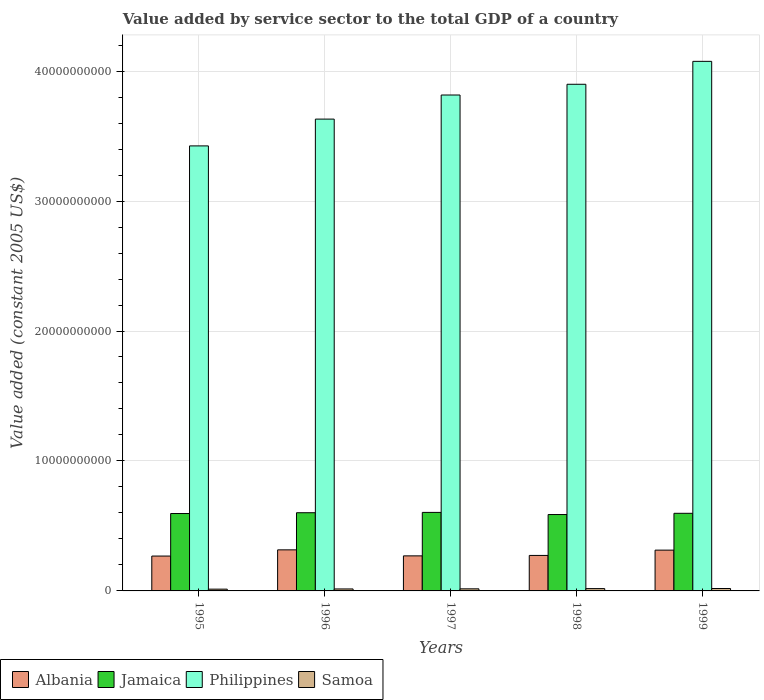How many different coloured bars are there?
Your answer should be very brief. 4. How many groups of bars are there?
Your response must be concise. 5. Are the number of bars per tick equal to the number of legend labels?
Give a very brief answer. Yes. Are the number of bars on each tick of the X-axis equal?
Give a very brief answer. Yes. What is the label of the 4th group of bars from the left?
Make the answer very short. 1998. In how many cases, is the number of bars for a given year not equal to the number of legend labels?
Offer a very short reply. 0. What is the value added by service sector in Samoa in 1996?
Ensure brevity in your answer.  1.52e+08. Across all years, what is the maximum value added by service sector in Albania?
Your answer should be compact. 3.16e+09. Across all years, what is the minimum value added by service sector in Jamaica?
Your response must be concise. 5.88e+09. In which year was the value added by service sector in Jamaica minimum?
Offer a terse response. 1998. What is the total value added by service sector in Albania in the graph?
Offer a terse response. 1.44e+1. What is the difference between the value added by service sector in Albania in 1995 and that in 1998?
Keep it short and to the point. -4.81e+07. What is the difference between the value added by service sector in Philippines in 1998 and the value added by service sector in Jamaica in 1995?
Your response must be concise. 3.30e+1. What is the average value added by service sector in Samoa per year?
Your answer should be compact. 1.63e+08. In the year 1996, what is the difference between the value added by service sector in Jamaica and value added by service sector in Albania?
Provide a succinct answer. 2.86e+09. In how many years, is the value added by service sector in Jamaica greater than 38000000000 US$?
Make the answer very short. 0. What is the ratio of the value added by service sector in Philippines in 1995 to that in 1996?
Ensure brevity in your answer.  0.94. Is the value added by service sector in Samoa in 1996 less than that in 1999?
Ensure brevity in your answer.  Yes. Is the difference between the value added by service sector in Jamaica in 1998 and 1999 greater than the difference between the value added by service sector in Albania in 1998 and 1999?
Provide a succinct answer. Yes. What is the difference between the highest and the second highest value added by service sector in Jamaica?
Your answer should be very brief. 2.46e+07. What is the difference between the highest and the lowest value added by service sector in Samoa?
Offer a terse response. 4.87e+07. Is the sum of the value added by service sector in Philippines in 1997 and 1998 greater than the maximum value added by service sector in Samoa across all years?
Provide a succinct answer. Yes. What does the 4th bar from the left in 1996 represents?
Your response must be concise. Samoa. What does the 3rd bar from the right in 1998 represents?
Provide a short and direct response. Jamaica. Is it the case that in every year, the sum of the value added by service sector in Samoa and value added by service sector in Albania is greater than the value added by service sector in Philippines?
Give a very brief answer. No. How many bars are there?
Provide a short and direct response. 20. Does the graph contain grids?
Provide a short and direct response. Yes. What is the title of the graph?
Provide a short and direct response. Value added by service sector to the total GDP of a country. What is the label or title of the X-axis?
Offer a very short reply. Years. What is the label or title of the Y-axis?
Provide a succinct answer. Value added (constant 2005 US$). What is the Value added (constant 2005 US$) in Albania in 1995?
Make the answer very short. 2.68e+09. What is the Value added (constant 2005 US$) of Jamaica in 1995?
Your answer should be very brief. 5.96e+09. What is the Value added (constant 2005 US$) in Philippines in 1995?
Keep it short and to the point. 3.42e+1. What is the Value added (constant 2005 US$) of Samoa in 1995?
Offer a terse response. 1.37e+08. What is the Value added (constant 2005 US$) of Albania in 1996?
Offer a very short reply. 3.16e+09. What is the Value added (constant 2005 US$) in Jamaica in 1996?
Your response must be concise. 6.02e+09. What is the Value added (constant 2005 US$) in Philippines in 1996?
Your response must be concise. 3.63e+1. What is the Value added (constant 2005 US$) of Samoa in 1996?
Your answer should be compact. 1.52e+08. What is the Value added (constant 2005 US$) in Albania in 1997?
Provide a short and direct response. 2.70e+09. What is the Value added (constant 2005 US$) of Jamaica in 1997?
Give a very brief answer. 6.04e+09. What is the Value added (constant 2005 US$) of Philippines in 1997?
Offer a very short reply. 3.82e+1. What is the Value added (constant 2005 US$) of Samoa in 1997?
Offer a very short reply. 1.60e+08. What is the Value added (constant 2005 US$) in Albania in 1998?
Offer a very short reply. 2.73e+09. What is the Value added (constant 2005 US$) in Jamaica in 1998?
Give a very brief answer. 5.88e+09. What is the Value added (constant 2005 US$) in Philippines in 1998?
Provide a short and direct response. 3.90e+1. What is the Value added (constant 2005 US$) in Samoa in 1998?
Provide a succinct answer. 1.78e+08. What is the Value added (constant 2005 US$) of Albania in 1999?
Your answer should be very brief. 3.14e+09. What is the Value added (constant 2005 US$) of Jamaica in 1999?
Offer a terse response. 5.97e+09. What is the Value added (constant 2005 US$) of Philippines in 1999?
Your answer should be very brief. 4.07e+1. What is the Value added (constant 2005 US$) in Samoa in 1999?
Provide a succinct answer. 1.86e+08. Across all years, what is the maximum Value added (constant 2005 US$) of Albania?
Provide a succinct answer. 3.16e+09. Across all years, what is the maximum Value added (constant 2005 US$) in Jamaica?
Ensure brevity in your answer.  6.04e+09. Across all years, what is the maximum Value added (constant 2005 US$) in Philippines?
Your answer should be compact. 4.07e+1. Across all years, what is the maximum Value added (constant 2005 US$) in Samoa?
Ensure brevity in your answer.  1.86e+08. Across all years, what is the minimum Value added (constant 2005 US$) in Albania?
Ensure brevity in your answer.  2.68e+09. Across all years, what is the minimum Value added (constant 2005 US$) in Jamaica?
Make the answer very short. 5.88e+09. Across all years, what is the minimum Value added (constant 2005 US$) in Philippines?
Offer a very short reply. 3.42e+1. Across all years, what is the minimum Value added (constant 2005 US$) of Samoa?
Give a very brief answer. 1.37e+08. What is the total Value added (constant 2005 US$) in Albania in the graph?
Offer a terse response. 1.44e+1. What is the total Value added (constant 2005 US$) of Jamaica in the graph?
Offer a terse response. 2.99e+1. What is the total Value added (constant 2005 US$) of Philippines in the graph?
Ensure brevity in your answer.  1.88e+11. What is the total Value added (constant 2005 US$) of Samoa in the graph?
Provide a succinct answer. 8.13e+08. What is the difference between the Value added (constant 2005 US$) in Albania in 1995 and that in 1996?
Keep it short and to the point. -4.78e+08. What is the difference between the Value added (constant 2005 US$) in Jamaica in 1995 and that in 1996?
Your response must be concise. -6.16e+07. What is the difference between the Value added (constant 2005 US$) in Philippines in 1995 and that in 1996?
Keep it short and to the point. -2.06e+09. What is the difference between the Value added (constant 2005 US$) of Samoa in 1995 and that in 1996?
Your answer should be compact. -1.48e+07. What is the difference between the Value added (constant 2005 US$) of Albania in 1995 and that in 1997?
Offer a very short reply. -1.41e+07. What is the difference between the Value added (constant 2005 US$) in Jamaica in 1995 and that in 1997?
Your response must be concise. -8.62e+07. What is the difference between the Value added (constant 2005 US$) of Philippines in 1995 and that in 1997?
Ensure brevity in your answer.  -3.92e+09. What is the difference between the Value added (constant 2005 US$) in Samoa in 1995 and that in 1997?
Your answer should be compact. -2.35e+07. What is the difference between the Value added (constant 2005 US$) of Albania in 1995 and that in 1998?
Give a very brief answer. -4.81e+07. What is the difference between the Value added (constant 2005 US$) of Jamaica in 1995 and that in 1998?
Your response must be concise. 7.83e+07. What is the difference between the Value added (constant 2005 US$) of Philippines in 1995 and that in 1998?
Offer a terse response. -4.74e+09. What is the difference between the Value added (constant 2005 US$) of Samoa in 1995 and that in 1998?
Keep it short and to the point. -4.14e+07. What is the difference between the Value added (constant 2005 US$) of Albania in 1995 and that in 1999?
Keep it short and to the point. -4.56e+08. What is the difference between the Value added (constant 2005 US$) in Jamaica in 1995 and that in 1999?
Provide a succinct answer. -1.67e+07. What is the difference between the Value added (constant 2005 US$) in Philippines in 1995 and that in 1999?
Offer a very short reply. -6.51e+09. What is the difference between the Value added (constant 2005 US$) of Samoa in 1995 and that in 1999?
Provide a short and direct response. -4.87e+07. What is the difference between the Value added (constant 2005 US$) in Albania in 1996 and that in 1997?
Provide a succinct answer. 4.64e+08. What is the difference between the Value added (constant 2005 US$) in Jamaica in 1996 and that in 1997?
Ensure brevity in your answer.  -2.46e+07. What is the difference between the Value added (constant 2005 US$) in Philippines in 1996 and that in 1997?
Your answer should be very brief. -1.85e+09. What is the difference between the Value added (constant 2005 US$) in Samoa in 1996 and that in 1997?
Give a very brief answer. -8.70e+06. What is the difference between the Value added (constant 2005 US$) of Albania in 1996 and that in 1998?
Your answer should be very brief. 4.30e+08. What is the difference between the Value added (constant 2005 US$) of Jamaica in 1996 and that in 1998?
Your answer should be compact. 1.40e+08. What is the difference between the Value added (constant 2005 US$) of Philippines in 1996 and that in 1998?
Keep it short and to the point. -2.68e+09. What is the difference between the Value added (constant 2005 US$) in Samoa in 1996 and that in 1998?
Provide a succinct answer. -2.65e+07. What is the difference between the Value added (constant 2005 US$) in Albania in 1996 and that in 1999?
Keep it short and to the point. 2.20e+07. What is the difference between the Value added (constant 2005 US$) in Jamaica in 1996 and that in 1999?
Ensure brevity in your answer.  4.48e+07. What is the difference between the Value added (constant 2005 US$) in Philippines in 1996 and that in 1999?
Your response must be concise. -4.44e+09. What is the difference between the Value added (constant 2005 US$) of Samoa in 1996 and that in 1999?
Offer a very short reply. -3.39e+07. What is the difference between the Value added (constant 2005 US$) in Albania in 1997 and that in 1998?
Your response must be concise. -3.40e+07. What is the difference between the Value added (constant 2005 US$) of Jamaica in 1997 and that in 1998?
Offer a terse response. 1.64e+08. What is the difference between the Value added (constant 2005 US$) of Philippines in 1997 and that in 1998?
Provide a succinct answer. -8.26e+08. What is the difference between the Value added (constant 2005 US$) in Samoa in 1997 and that in 1998?
Your answer should be compact. -1.78e+07. What is the difference between the Value added (constant 2005 US$) in Albania in 1997 and that in 1999?
Provide a short and direct response. -4.42e+08. What is the difference between the Value added (constant 2005 US$) in Jamaica in 1997 and that in 1999?
Give a very brief answer. 6.94e+07. What is the difference between the Value added (constant 2005 US$) in Philippines in 1997 and that in 1999?
Offer a terse response. -2.59e+09. What is the difference between the Value added (constant 2005 US$) of Samoa in 1997 and that in 1999?
Make the answer very short. -2.52e+07. What is the difference between the Value added (constant 2005 US$) in Albania in 1998 and that in 1999?
Give a very brief answer. -4.08e+08. What is the difference between the Value added (constant 2005 US$) of Jamaica in 1998 and that in 1999?
Keep it short and to the point. -9.51e+07. What is the difference between the Value added (constant 2005 US$) of Philippines in 1998 and that in 1999?
Offer a very short reply. -1.76e+09. What is the difference between the Value added (constant 2005 US$) of Samoa in 1998 and that in 1999?
Ensure brevity in your answer.  -7.37e+06. What is the difference between the Value added (constant 2005 US$) in Albania in 1995 and the Value added (constant 2005 US$) in Jamaica in 1996?
Keep it short and to the point. -3.33e+09. What is the difference between the Value added (constant 2005 US$) in Albania in 1995 and the Value added (constant 2005 US$) in Philippines in 1996?
Offer a terse response. -3.36e+1. What is the difference between the Value added (constant 2005 US$) in Albania in 1995 and the Value added (constant 2005 US$) in Samoa in 1996?
Keep it short and to the point. 2.53e+09. What is the difference between the Value added (constant 2005 US$) in Jamaica in 1995 and the Value added (constant 2005 US$) in Philippines in 1996?
Give a very brief answer. -3.03e+1. What is the difference between the Value added (constant 2005 US$) of Jamaica in 1995 and the Value added (constant 2005 US$) of Samoa in 1996?
Give a very brief answer. 5.80e+09. What is the difference between the Value added (constant 2005 US$) in Philippines in 1995 and the Value added (constant 2005 US$) in Samoa in 1996?
Provide a succinct answer. 3.41e+1. What is the difference between the Value added (constant 2005 US$) of Albania in 1995 and the Value added (constant 2005 US$) of Jamaica in 1997?
Offer a terse response. -3.36e+09. What is the difference between the Value added (constant 2005 US$) of Albania in 1995 and the Value added (constant 2005 US$) of Philippines in 1997?
Your response must be concise. -3.55e+1. What is the difference between the Value added (constant 2005 US$) of Albania in 1995 and the Value added (constant 2005 US$) of Samoa in 1997?
Offer a terse response. 2.52e+09. What is the difference between the Value added (constant 2005 US$) of Jamaica in 1995 and the Value added (constant 2005 US$) of Philippines in 1997?
Your answer should be compact. -3.22e+1. What is the difference between the Value added (constant 2005 US$) in Jamaica in 1995 and the Value added (constant 2005 US$) in Samoa in 1997?
Provide a succinct answer. 5.80e+09. What is the difference between the Value added (constant 2005 US$) in Philippines in 1995 and the Value added (constant 2005 US$) in Samoa in 1997?
Your response must be concise. 3.41e+1. What is the difference between the Value added (constant 2005 US$) of Albania in 1995 and the Value added (constant 2005 US$) of Jamaica in 1998?
Keep it short and to the point. -3.19e+09. What is the difference between the Value added (constant 2005 US$) in Albania in 1995 and the Value added (constant 2005 US$) in Philippines in 1998?
Your answer should be compact. -3.63e+1. What is the difference between the Value added (constant 2005 US$) of Albania in 1995 and the Value added (constant 2005 US$) of Samoa in 1998?
Your answer should be compact. 2.50e+09. What is the difference between the Value added (constant 2005 US$) in Jamaica in 1995 and the Value added (constant 2005 US$) in Philippines in 1998?
Your response must be concise. -3.30e+1. What is the difference between the Value added (constant 2005 US$) of Jamaica in 1995 and the Value added (constant 2005 US$) of Samoa in 1998?
Make the answer very short. 5.78e+09. What is the difference between the Value added (constant 2005 US$) in Philippines in 1995 and the Value added (constant 2005 US$) in Samoa in 1998?
Provide a succinct answer. 3.41e+1. What is the difference between the Value added (constant 2005 US$) in Albania in 1995 and the Value added (constant 2005 US$) in Jamaica in 1999?
Your answer should be compact. -3.29e+09. What is the difference between the Value added (constant 2005 US$) of Albania in 1995 and the Value added (constant 2005 US$) of Philippines in 1999?
Provide a succinct answer. -3.81e+1. What is the difference between the Value added (constant 2005 US$) in Albania in 1995 and the Value added (constant 2005 US$) in Samoa in 1999?
Offer a terse response. 2.50e+09. What is the difference between the Value added (constant 2005 US$) in Jamaica in 1995 and the Value added (constant 2005 US$) in Philippines in 1999?
Ensure brevity in your answer.  -3.48e+1. What is the difference between the Value added (constant 2005 US$) of Jamaica in 1995 and the Value added (constant 2005 US$) of Samoa in 1999?
Your response must be concise. 5.77e+09. What is the difference between the Value added (constant 2005 US$) in Philippines in 1995 and the Value added (constant 2005 US$) in Samoa in 1999?
Your answer should be very brief. 3.41e+1. What is the difference between the Value added (constant 2005 US$) of Albania in 1996 and the Value added (constant 2005 US$) of Jamaica in 1997?
Make the answer very short. -2.88e+09. What is the difference between the Value added (constant 2005 US$) in Albania in 1996 and the Value added (constant 2005 US$) in Philippines in 1997?
Your answer should be compact. -3.50e+1. What is the difference between the Value added (constant 2005 US$) of Albania in 1996 and the Value added (constant 2005 US$) of Samoa in 1997?
Ensure brevity in your answer.  3.00e+09. What is the difference between the Value added (constant 2005 US$) in Jamaica in 1996 and the Value added (constant 2005 US$) in Philippines in 1997?
Provide a short and direct response. -3.21e+1. What is the difference between the Value added (constant 2005 US$) in Jamaica in 1996 and the Value added (constant 2005 US$) in Samoa in 1997?
Make the answer very short. 5.86e+09. What is the difference between the Value added (constant 2005 US$) in Philippines in 1996 and the Value added (constant 2005 US$) in Samoa in 1997?
Provide a succinct answer. 3.61e+1. What is the difference between the Value added (constant 2005 US$) of Albania in 1996 and the Value added (constant 2005 US$) of Jamaica in 1998?
Make the answer very short. -2.72e+09. What is the difference between the Value added (constant 2005 US$) in Albania in 1996 and the Value added (constant 2005 US$) in Philippines in 1998?
Provide a short and direct response. -3.58e+1. What is the difference between the Value added (constant 2005 US$) of Albania in 1996 and the Value added (constant 2005 US$) of Samoa in 1998?
Ensure brevity in your answer.  2.98e+09. What is the difference between the Value added (constant 2005 US$) in Jamaica in 1996 and the Value added (constant 2005 US$) in Philippines in 1998?
Keep it short and to the point. -3.30e+1. What is the difference between the Value added (constant 2005 US$) of Jamaica in 1996 and the Value added (constant 2005 US$) of Samoa in 1998?
Give a very brief answer. 5.84e+09. What is the difference between the Value added (constant 2005 US$) of Philippines in 1996 and the Value added (constant 2005 US$) of Samoa in 1998?
Your response must be concise. 3.61e+1. What is the difference between the Value added (constant 2005 US$) of Albania in 1996 and the Value added (constant 2005 US$) of Jamaica in 1999?
Your answer should be compact. -2.81e+09. What is the difference between the Value added (constant 2005 US$) of Albania in 1996 and the Value added (constant 2005 US$) of Philippines in 1999?
Your answer should be compact. -3.76e+1. What is the difference between the Value added (constant 2005 US$) in Albania in 1996 and the Value added (constant 2005 US$) in Samoa in 1999?
Your answer should be compact. 2.98e+09. What is the difference between the Value added (constant 2005 US$) in Jamaica in 1996 and the Value added (constant 2005 US$) in Philippines in 1999?
Provide a short and direct response. -3.47e+1. What is the difference between the Value added (constant 2005 US$) of Jamaica in 1996 and the Value added (constant 2005 US$) of Samoa in 1999?
Offer a very short reply. 5.83e+09. What is the difference between the Value added (constant 2005 US$) of Philippines in 1996 and the Value added (constant 2005 US$) of Samoa in 1999?
Ensure brevity in your answer.  3.61e+1. What is the difference between the Value added (constant 2005 US$) in Albania in 1997 and the Value added (constant 2005 US$) in Jamaica in 1998?
Offer a very short reply. -3.18e+09. What is the difference between the Value added (constant 2005 US$) in Albania in 1997 and the Value added (constant 2005 US$) in Philippines in 1998?
Give a very brief answer. -3.63e+1. What is the difference between the Value added (constant 2005 US$) in Albania in 1997 and the Value added (constant 2005 US$) in Samoa in 1998?
Offer a terse response. 2.52e+09. What is the difference between the Value added (constant 2005 US$) in Jamaica in 1997 and the Value added (constant 2005 US$) in Philippines in 1998?
Keep it short and to the point. -3.29e+1. What is the difference between the Value added (constant 2005 US$) in Jamaica in 1997 and the Value added (constant 2005 US$) in Samoa in 1998?
Make the answer very short. 5.86e+09. What is the difference between the Value added (constant 2005 US$) in Philippines in 1997 and the Value added (constant 2005 US$) in Samoa in 1998?
Your answer should be compact. 3.80e+1. What is the difference between the Value added (constant 2005 US$) of Albania in 1997 and the Value added (constant 2005 US$) of Jamaica in 1999?
Give a very brief answer. -3.28e+09. What is the difference between the Value added (constant 2005 US$) of Albania in 1997 and the Value added (constant 2005 US$) of Philippines in 1999?
Your response must be concise. -3.81e+1. What is the difference between the Value added (constant 2005 US$) of Albania in 1997 and the Value added (constant 2005 US$) of Samoa in 1999?
Offer a very short reply. 2.51e+09. What is the difference between the Value added (constant 2005 US$) of Jamaica in 1997 and the Value added (constant 2005 US$) of Philippines in 1999?
Ensure brevity in your answer.  -3.47e+1. What is the difference between the Value added (constant 2005 US$) in Jamaica in 1997 and the Value added (constant 2005 US$) in Samoa in 1999?
Give a very brief answer. 5.86e+09. What is the difference between the Value added (constant 2005 US$) of Philippines in 1997 and the Value added (constant 2005 US$) of Samoa in 1999?
Give a very brief answer. 3.80e+1. What is the difference between the Value added (constant 2005 US$) of Albania in 1998 and the Value added (constant 2005 US$) of Jamaica in 1999?
Offer a terse response. -3.24e+09. What is the difference between the Value added (constant 2005 US$) of Albania in 1998 and the Value added (constant 2005 US$) of Philippines in 1999?
Give a very brief answer. -3.80e+1. What is the difference between the Value added (constant 2005 US$) in Albania in 1998 and the Value added (constant 2005 US$) in Samoa in 1999?
Ensure brevity in your answer.  2.55e+09. What is the difference between the Value added (constant 2005 US$) of Jamaica in 1998 and the Value added (constant 2005 US$) of Philippines in 1999?
Give a very brief answer. -3.49e+1. What is the difference between the Value added (constant 2005 US$) in Jamaica in 1998 and the Value added (constant 2005 US$) in Samoa in 1999?
Keep it short and to the point. 5.69e+09. What is the difference between the Value added (constant 2005 US$) in Philippines in 1998 and the Value added (constant 2005 US$) in Samoa in 1999?
Your response must be concise. 3.88e+1. What is the average Value added (constant 2005 US$) in Albania per year?
Keep it short and to the point. 2.88e+09. What is the average Value added (constant 2005 US$) in Jamaica per year?
Provide a short and direct response. 5.97e+09. What is the average Value added (constant 2005 US$) in Philippines per year?
Your response must be concise. 3.77e+1. What is the average Value added (constant 2005 US$) in Samoa per year?
Keep it short and to the point. 1.63e+08. In the year 1995, what is the difference between the Value added (constant 2005 US$) of Albania and Value added (constant 2005 US$) of Jamaica?
Your answer should be compact. -3.27e+09. In the year 1995, what is the difference between the Value added (constant 2005 US$) in Albania and Value added (constant 2005 US$) in Philippines?
Your response must be concise. -3.16e+1. In the year 1995, what is the difference between the Value added (constant 2005 US$) of Albania and Value added (constant 2005 US$) of Samoa?
Give a very brief answer. 2.55e+09. In the year 1995, what is the difference between the Value added (constant 2005 US$) of Jamaica and Value added (constant 2005 US$) of Philippines?
Offer a very short reply. -2.83e+1. In the year 1995, what is the difference between the Value added (constant 2005 US$) in Jamaica and Value added (constant 2005 US$) in Samoa?
Provide a succinct answer. 5.82e+09. In the year 1995, what is the difference between the Value added (constant 2005 US$) in Philippines and Value added (constant 2005 US$) in Samoa?
Your answer should be very brief. 3.41e+1. In the year 1996, what is the difference between the Value added (constant 2005 US$) in Albania and Value added (constant 2005 US$) in Jamaica?
Provide a succinct answer. -2.86e+09. In the year 1996, what is the difference between the Value added (constant 2005 US$) of Albania and Value added (constant 2005 US$) of Philippines?
Your answer should be very brief. -3.31e+1. In the year 1996, what is the difference between the Value added (constant 2005 US$) of Albania and Value added (constant 2005 US$) of Samoa?
Give a very brief answer. 3.01e+09. In the year 1996, what is the difference between the Value added (constant 2005 US$) of Jamaica and Value added (constant 2005 US$) of Philippines?
Make the answer very short. -3.03e+1. In the year 1996, what is the difference between the Value added (constant 2005 US$) of Jamaica and Value added (constant 2005 US$) of Samoa?
Your answer should be compact. 5.87e+09. In the year 1996, what is the difference between the Value added (constant 2005 US$) of Philippines and Value added (constant 2005 US$) of Samoa?
Offer a very short reply. 3.62e+1. In the year 1997, what is the difference between the Value added (constant 2005 US$) of Albania and Value added (constant 2005 US$) of Jamaica?
Offer a very short reply. -3.34e+09. In the year 1997, what is the difference between the Value added (constant 2005 US$) in Albania and Value added (constant 2005 US$) in Philippines?
Offer a terse response. -3.55e+1. In the year 1997, what is the difference between the Value added (constant 2005 US$) in Albania and Value added (constant 2005 US$) in Samoa?
Offer a very short reply. 2.54e+09. In the year 1997, what is the difference between the Value added (constant 2005 US$) in Jamaica and Value added (constant 2005 US$) in Philippines?
Your response must be concise. -3.21e+1. In the year 1997, what is the difference between the Value added (constant 2005 US$) in Jamaica and Value added (constant 2005 US$) in Samoa?
Your answer should be compact. 5.88e+09. In the year 1997, what is the difference between the Value added (constant 2005 US$) in Philippines and Value added (constant 2005 US$) in Samoa?
Your answer should be very brief. 3.80e+1. In the year 1998, what is the difference between the Value added (constant 2005 US$) of Albania and Value added (constant 2005 US$) of Jamaica?
Offer a very short reply. -3.15e+09. In the year 1998, what is the difference between the Value added (constant 2005 US$) in Albania and Value added (constant 2005 US$) in Philippines?
Offer a very short reply. -3.63e+1. In the year 1998, what is the difference between the Value added (constant 2005 US$) in Albania and Value added (constant 2005 US$) in Samoa?
Your response must be concise. 2.55e+09. In the year 1998, what is the difference between the Value added (constant 2005 US$) in Jamaica and Value added (constant 2005 US$) in Philippines?
Your response must be concise. -3.31e+1. In the year 1998, what is the difference between the Value added (constant 2005 US$) of Jamaica and Value added (constant 2005 US$) of Samoa?
Give a very brief answer. 5.70e+09. In the year 1998, what is the difference between the Value added (constant 2005 US$) of Philippines and Value added (constant 2005 US$) of Samoa?
Provide a short and direct response. 3.88e+1. In the year 1999, what is the difference between the Value added (constant 2005 US$) of Albania and Value added (constant 2005 US$) of Jamaica?
Offer a terse response. -2.83e+09. In the year 1999, what is the difference between the Value added (constant 2005 US$) of Albania and Value added (constant 2005 US$) of Philippines?
Your response must be concise. -3.76e+1. In the year 1999, what is the difference between the Value added (constant 2005 US$) in Albania and Value added (constant 2005 US$) in Samoa?
Your answer should be very brief. 2.95e+09. In the year 1999, what is the difference between the Value added (constant 2005 US$) in Jamaica and Value added (constant 2005 US$) in Philippines?
Your answer should be compact. -3.48e+1. In the year 1999, what is the difference between the Value added (constant 2005 US$) of Jamaica and Value added (constant 2005 US$) of Samoa?
Your response must be concise. 5.79e+09. In the year 1999, what is the difference between the Value added (constant 2005 US$) of Philippines and Value added (constant 2005 US$) of Samoa?
Your answer should be compact. 4.06e+1. What is the ratio of the Value added (constant 2005 US$) in Albania in 1995 to that in 1996?
Offer a very short reply. 0.85. What is the ratio of the Value added (constant 2005 US$) of Jamaica in 1995 to that in 1996?
Your response must be concise. 0.99. What is the ratio of the Value added (constant 2005 US$) in Philippines in 1995 to that in 1996?
Ensure brevity in your answer.  0.94. What is the ratio of the Value added (constant 2005 US$) in Samoa in 1995 to that in 1996?
Keep it short and to the point. 0.9. What is the ratio of the Value added (constant 2005 US$) of Jamaica in 1995 to that in 1997?
Provide a short and direct response. 0.99. What is the ratio of the Value added (constant 2005 US$) of Philippines in 1995 to that in 1997?
Your answer should be compact. 0.9. What is the ratio of the Value added (constant 2005 US$) in Samoa in 1995 to that in 1997?
Provide a succinct answer. 0.85. What is the ratio of the Value added (constant 2005 US$) in Albania in 1995 to that in 1998?
Make the answer very short. 0.98. What is the ratio of the Value added (constant 2005 US$) in Jamaica in 1995 to that in 1998?
Keep it short and to the point. 1.01. What is the ratio of the Value added (constant 2005 US$) of Philippines in 1995 to that in 1998?
Make the answer very short. 0.88. What is the ratio of the Value added (constant 2005 US$) in Samoa in 1995 to that in 1998?
Ensure brevity in your answer.  0.77. What is the ratio of the Value added (constant 2005 US$) of Albania in 1995 to that in 1999?
Provide a succinct answer. 0.85. What is the ratio of the Value added (constant 2005 US$) of Philippines in 1995 to that in 1999?
Provide a succinct answer. 0.84. What is the ratio of the Value added (constant 2005 US$) in Samoa in 1995 to that in 1999?
Offer a very short reply. 0.74. What is the ratio of the Value added (constant 2005 US$) in Albania in 1996 to that in 1997?
Provide a short and direct response. 1.17. What is the ratio of the Value added (constant 2005 US$) in Jamaica in 1996 to that in 1997?
Your answer should be very brief. 1. What is the ratio of the Value added (constant 2005 US$) of Philippines in 1996 to that in 1997?
Make the answer very short. 0.95. What is the ratio of the Value added (constant 2005 US$) of Samoa in 1996 to that in 1997?
Your response must be concise. 0.95. What is the ratio of the Value added (constant 2005 US$) in Albania in 1996 to that in 1998?
Ensure brevity in your answer.  1.16. What is the ratio of the Value added (constant 2005 US$) in Jamaica in 1996 to that in 1998?
Ensure brevity in your answer.  1.02. What is the ratio of the Value added (constant 2005 US$) of Philippines in 1996 to that in 1998?
Keep it short and to the point. 0.93. What is the ratio of the Value added (constant 2005 US$) of Samoa in 1996 to that in 1998?
Your response must be concise. 0.85. What is the ratio of the Value added (constant 2005 US$) in Albania in 1996 to that in 1999?
Provide a succinct answer. 1.01. What is the ratio of the Value added (constant 2005 US$) in Jamaica in 1996 to that in 1999?
Your answer should be compact. 1.01. What is the ratio of the Value added (constant 2005 US$) of Philippines in 1996 to that in 1999?
Provide a succinct answer. 0.89. What is the ratio of the Value added (constant 2005 US$) in Samoa in 1996 to that in 1999?
Offer a terse response. 0.82. What is the ratio of the Value added (constant 2005 US$) in Albania in 1997 to that in 1998?
Your answer should be compact. 0.99. What is the ratio of the Value added (constant 2005 US$) of Jamaica in 1997 to that in 1998?
Your response must be concise. 1.03. What is the ratio of the Value added (constant 2005 US$) in Philippines in 1997 to that in 1998?
Give a very brief answer. 0.98. What is the ratio of the Value added (constant 2005 US$) of Samoa in 1997 to that in 1998?
Your response must be concise. 0.9. What is the ratio of the Value added (constant 2005 US$) of Albania in 1997 to that in 1999?
Keep it short and to the point. 0.86. What is the ratio of the Value added (constant 2005 US$) of Jamaica in 1997 to that in 1999?
Offer a very short reply. 1.01. What is the ratio of the Value added (constant 2005 US$) in Philippines in 1997 to that in 1999?
Give a very brief answer. 0.94. What is the ratio of the Value added (constant 2005 US$) of Samoa in 1997 to that in 1999?
Your answer should be very brief. 0.86. What is the ratio of the Value added (constant 2005 US$) in Albania in 1998 to that in 1999?
Ensure brevity in your answer.  0.87. What is the ratio of the Value added (constant 2005 US$) in Jamaica in 1998 to that in 1999?
Offer a terse response. 0.98. What is the ratio of the Value added (constant 2005 US$) in Philippines in 1998 to that in 1999?
Make the answer very short. 0.96. What is the ratio of the Value added (constant 2005 US$) of Samoa in 1998 to that in 1999?
Offer a terse response. 0.96. What is the difference between the highest and the second highest Value added (constant 2005 US$) in Albania?
Provide a short and direct response. 2.20e+07. What is the difference between the highest and the second highest Value added (constant 2005 US$) of Jamaica?
Offer a very short reply. 2.46e+07. What is the difference between the highest and the second highest Value added (constant 2005 US$) of Philippines?
Offer a terse response. 1.76e+09. What is the difference between the highest and the second highest Value added (constant 2005 US$) in Samoa?
Offer a very short reply. 7.37e+06. What is the difference between the highest and the lowest Value added (constant 2005 US$) in Albania?
Keep it short and to the point. 4.78e+08. What is the difference between the highest and the lowest Value added (constant 2005 US$) in Jamaica?
Offer a terse response. 1.64e+08. What is the difference between the highest and the lowest Value added (constant 2005 US$) of Philippines?
Give a very brief answer. 6.51e+09. What is the difference between the highest and the lowest Value added (constant 2005 US$) of Samoa?
Offer a very short reply. 4.87e+07. 